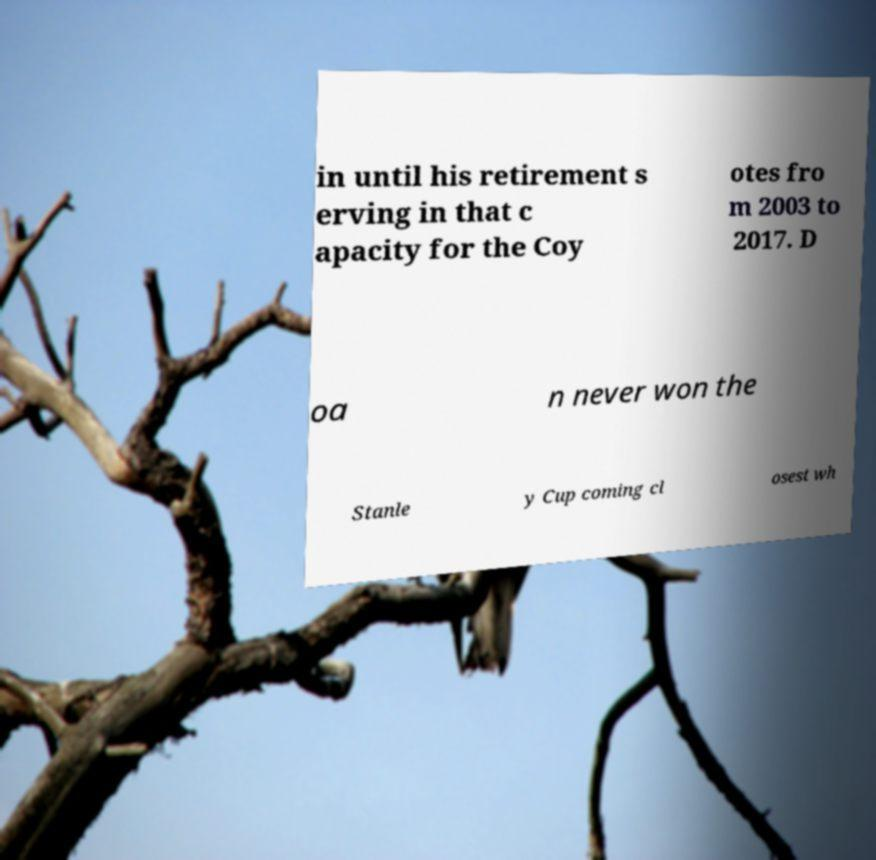What messages or text are displayed in this image? I need them in a readable, typed format. in until his retirement s erving in that c apacity for the Coy otes fro m 2003 to 2017. D oa n never won the Stanle y Cup coming cl osest wh 